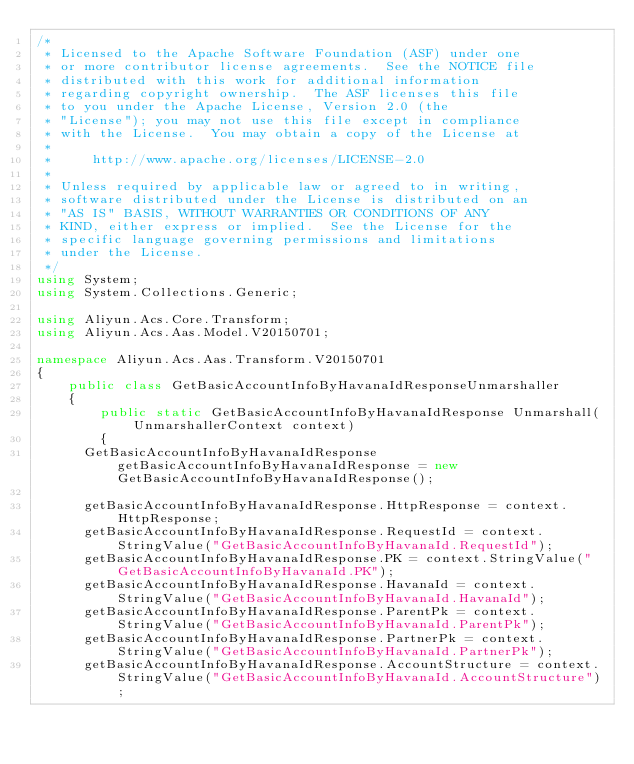<code> <loc_0><loc_0><loc_500><loc_500><_C#_>/*
 * Licensed to the Apache Software Foundation (ASF) under one
 * or more contributor license agreements.  See the NOTICE file
 * distributed with this work for additional information
 * regarding copyright ownership.  The ASF licenses this file
 * to you under the Apache License, Version 2.0 (the
 * "License"); you may not use this file except in compliance
 * with the License.  You may obtain a copy of the License at
 *
 *     http://www.apache.org/licenses/LICENSE-2.0
 *
 * Unless required by applicable law or agreed to in writing,
 * software distributed under the License is distributed on an
 * "AS IS" BASIS, WITHOUT WARRANTIES OR CONDITIONS OF ANY
 * KIND, either express or implied.  See the License for the
 * specific language governing permissions and limitations
 * under the License.
 */
using System;
using System.Collections.Generic;

using Aliyun.Acs.Core.Transform;
using Aliyun.Acs.Aas.Model.V20150701;

namespace Aliyun.Acs.Aas.Transform.V20150701
{
    public class GetBasicAccountInfoByHavanaIdResponseUnmarshaller
    {
        public static GetBasicAccountInfoByHavanaIdResponse Unmarshall(UnmarshallerContext context)
        {
			GetBasicAccountInfoByHavanaIdResponse getBasicAccountInfoByHavanaIdResponse = new GetBasicAccountInfoByHavanaIdResponse();

			getBasicAccountInfoByHavanaIdResponse.HttpResponse = context.HttpResponse;
			getBasicAccountInfoByHavanaIdResponse.RequestId = context.StringValue("GetBasicAccountInfoByHavanaId.RequestId");
			getBasicAccountInfoByHavanaIdResponse.PK = context.StringValue("GetBasicAccountInfoByHavanaId.PK");
			getBasicAccountInfoByHavanaIdResponse.HavanaId = context.StringValue("GetBasicAccountInfoByHavanaId.HavanaId");
			getBasicAccountInfoByHavanaIdResponse.ParentPk = context.StringValue("GetBasicAccountInfoByHavanaId.ParentPk");
			getBasicAccountInfoByHavanaIdResponse.PartnerPk = context.StringValue("GetBasicAccountInfoByHavanaId.PartnerPk");
			getBasicAccountInfoByHavanaIdResponse.AccountStructure = context.StringValue("GetBasicAccountInfoByHavanaId.AccountStructure");</code> 